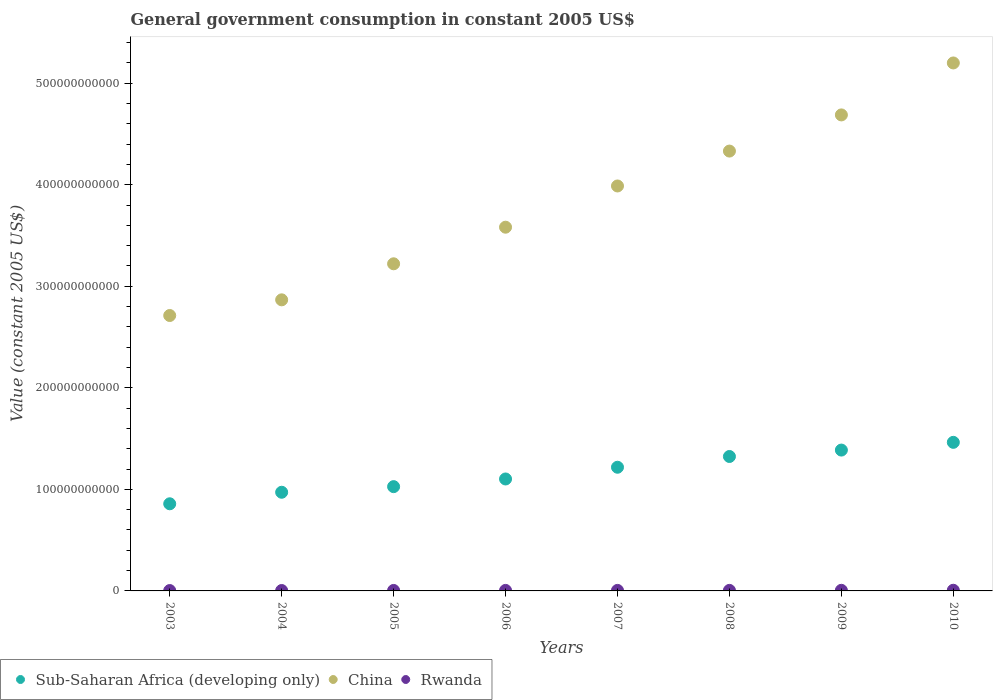What is the government conusmption in Rwanda in 2004?
Offer a terse response. 4.01e+08. Across all years, what is the maximum government conusmption in Sub-Saharan Africa (developing only)?
Ensure brevity in your answer.  1.46e+11. Across all years, what is the minimum government conusmption in China?
Provide a succinct answer. 2.71e+11. What is the total government conusmption in Rwanda in the graph?
Make the answer very short. 4.05e+09. What is the difference between the government conusmption in Sub-Saharan Africa (developing only) in 2005 and that in 2007?
Your response must be concise. -1.91e+1. What is the difference between the government conusmption in China in 2003 and the government conusmption in Rwanda in 2007?
Provide a short and direct response. 2.71e+11. What is the average government conusmption in Sub-Saharan Africa (developing only) per year?
Provide a succinct answer. 1.17e+11. In the year 2009, what is the difference between the government conusmption in Sub-Saharan Africa (developing only) and government conusmption in Rwanda?
Ensure brevity in your answer.  1.38e+11. In how many years, is the government conusmption in China greater than 500000000000 US$?
Your answer should be compact. 1. What is the ratio of the government conusmption in China in 2006 to that in 2010?
Your answer should be compact. 0.69. Is the difference between the government conusmption in Sub-Saharan Africa (developing only) in 2008 and 2009 greater than the difference between the government conusmption in Rwanda in 2008 and 2009?
Provide a succinct answer. No. What is the difference between the highest and the second highest government conusmption in China?
Provide a short and direct response. 5.12e+1. What is the difference between the highest and the lowest government conusmption in Sub-Saharan Africa (developing only)?
Keep it short and to the point. 6.05e+1. In how many years, is the government conusmption in Rwanda greater than the average government conusmption in Rwanda taken over all years?
Your answer should be very brief. 5. Is the government conusmption in China strictly greater than the government conusmption in Rwanda over the years?
Provide a succinct answer. Yes. Is the government conusmption in Sub-Saharan Africa (developing only) strictly less than the government conusmption in China over the years?
Your answer should be compact. Yes. How many dotlines are there?
Provide a succinct answer. 3. What is the difference between two consecutive major ticks on the Y-axis?
Your answer should be compact. 1.00e+11. Are the values on the major ticks of Y-axis written in scientific E-notation?
Your answer should be very brief. No. Does the graph contain any zero values?
Offer a terse response. No. Does the graph contain grids?
Ensure brevity in your answer.  No. How many legend labels are there?
Provide a succinct answer. 3. How are the legend labels stacked?
Provide a short and direct response. Horizontal. What is the title of the graph?
Your answer should be very brief. General government consumption in constant 2005 US$. Does "Kiribati" appear as one of the legend labels in the graph?
Give a very brief answer. No. What is the label or title of the X-axis?
Your response must be concise. Years. What is the label or title of the Y-axis?
Ensure brevity in your answer.  Value (constant 2005 US$). What is the Value (constant 2005 US$) in Sub-Saharan Africa (developing only) in 2003?
Your answer should be very brief. 8.58e+1. What is the Value (constant 2005 US$) of China in 2003?
Offer a very short reply. 2.71e+11. What is the Value (constant 2005 US$) of Rwanda in 2003?
Make the answer very short. 3.66e+08. What is the Value (constant 2005 US$) in Sub-Saharan Africa (developing only) in 2004?
Offer a very short reply. 9.72e+1. What is the Value (constant 2005 US$) of China in 2004?
Make the answer very short. 2.87e+11. What is the Value (constant 2005 US$) of Rwanda in 2004?
Ensure brevity in your answer.  4.01e+08. What is the Value (constant 2005 US$) in Sub-Saharan Africa (developing only) in 2005?
Your answer should be very brief. 1.03e+11. What is the Value (constant 2005 US$) in China in 2005?
Make the answer very short. 3.22e+11. What is the Value (constant 2005 US$) in Rwanda in 2005?
Keep it short and to the point. 4.70e+08. What is the Value (constant 2005 US$) of Sub-Saharan Africa (developing only) in 2006?
Give a very brief answer. 1.10e+11. What is the Value (constant 2005 US$) of China in 2006?
Provide a succinct answer. 3.58e+11. What is the Value (constant 2005 US$) in Rwanda in 2006?
Provide a short and direct response. 5.14e+08. What is the Value (constant 2005 US$) of Sub-Saharan Africa (developing only) in 2007?
Your response must be concise. 1.22e+11. What is the Value (constant 2005 US$) in China in 2007?
Give a very brief answer. 3.99e+11. What is the Value (constant 2005 US$) of Rwanda in 2007?
Provide a short and direct response. 5.19e+08. What is the Value (constant 2005 US$) in Sub-Saharan Africa (developing only) in 2008?
Provide a short and direct response. 1.32e+11. What is the Value (constant 2005 US$) of China in 2008?
Keep it short and to the point. 4.33e+11. What is the Value (constant 2005 US$) in Rwanda in 2008?
Offer a very short reply. 5.32e+08. What is the Value (constant 2005 US$) in Sub-Saharan Africa (developing only) in 2009?
Ensure brevity in your answer.  1.39e+11. What is the Value (constant 2005 US$) of China in 2009?
Offer a very short reply. 4.69e+11. What is the Value (constant 2005 US$) of Rwanda in 2009?
Offer a terse response. 5.94e+08. What is the Value (constant 2005 US$) of Sub-Saharan Africa (developing only) in 2010?
Provide a short and direct response. 1.46e+11. What is the Value (constant 2005 US$) of China in 2010?
Provide a succinct answer. 5.20e+11. What is the Value (constant 2005 US$) of Rwanda in 2010?
Your response must be concise. 6.55e+08. Across all years, what is the maximum Value (constant 2005 US$) of Sub-Saharan Africa (developing only)?
Your answer should be very brief. 1.46e+11. Across all years, what is the maximum Value (constant 2005 US$) of China?
Offer a very short reply. 5.20e+11. Across all years, what is the maximum Value (constant 2005 US$) of Rwanda?
Your answer should be compact. 6.55e+08. Across all years, what is the minimum Value (constant 2005 US$) of Sub-Saharan Africa (developing only)?
Offer a terse response. 8.58e+1. Across all years, what is the minimum Value (constant 2005 US$) of China?
Offer a very short reply. 2.71e+11. Across all years, what is the minimum Value (constant 2005 US$) of Rwanda?
Your answer should be very brief. 3.66e+08. What is the total Value (constant 2005 US$) of Sub-Saharan Africa (developing only) in the graph?
Your answer should be very brief. 9.35e+11. What is the total Value (constant 2005 US$) in China in the graph?
Offer a very short reply. 3.06e+12. What is the total Value (constant 2005 US$) of Rwanda in the graph?
Your answer should be compact. 4.05e+09. What is the difference between the Value (constant 2005 US$) in Sub-Saharan Africa (developing only) in 2003 and that in 2004?
Make the answer very short. -1.13e+1. What is the difference between the Value (constant 2005 US$) of China in 2003 and that in 2004?
Provide a short and direct response. -1.54e+1. What is the difference between the Value (constant 2005 US$) in Rwanda in 2003 and that in 2004?
Your answer should be compact. -3.50e+07. What is the difference between the Value (constant 2005 US$) of Sub-Saharan Africa (developing only) in 2003 and that in 2005?
Your answer should be compact. -1.69e+1. What is the difference between the Value (constant 2005 US$) in China in 2003 and that in 2005?
Your answer should be very brief. -5.09e+1. What is the difference between the Value (constant 2005 US$) in Rwanda in 2003 and that in 2005?
Ensure brevity in your answer.  -1.04e+08. What is the difference between the Value (constant 2005 US$) of Sub-Saharan Africa (developing only) in 2003 and that in 2006?
Provide a short and direct response. -2.44e+1. What is the difference between the Value (constant 2005 US$) in China in 2003 and that in 2006?
Your answer should be very brief. -8.70e+1. What is the difference between the Value (constant 2005 US$) in Rwanda in 2003 and that in 2006?
Make the answer very short. -1.48e+08. What is the difference between the Value (constant 2005 US$) in Sub-Saharan Africa (developing only) in 2003 and that in 2007?
Offer a very short reply. -3.60e+1. What is the difference between the Value (constant 2005 US$) in China in 2003 and that in 2007?
Provide a short and direct response. -1.28e+11. What is the difference between the Value (constant 2005 US$) of Rwanda in 2003 and that in 2007?
Ensure brevity in your answer.  -1.53e+08. What is the difference between the Value (constant 2005 US$) of Sub-Saharan Africa (developing only) in 2003 and that in 2008?
Provide a succinct answer. -4.66e+1. What is the difference between the Value (constant 2005 US$) of China in 2003 and that in 2008?
Your response must be concise. -1.62e+11. What is the difference between the Value (constant 2005 US$) of Rwanda in 2003 and that in 2008?
Your answer should be very brief. -1.66e+08. What is the difference between the Value (constant 2005 US$) in Sub-Saharan Africa (developing only) in 2003 and that in 2009?
Make the answer very short. -5.29e+1. What is the difference between the Value (constant 2005 US$) of China in 2003 and that in 2009?
Keep it short and to the point. -1.98e+11. What is the difference between the Value (constant 2005 US$) of Rwanda in 2003 and that in 2009?
Offer a very short reply. -2.28e+08. What is the difference between the Value (constant 2005 US$) of Sub-Saharan Africa (developing only) in 2003 and that in 2010?
Your answer should be very brief. -6.05e+1. What is the difference between the Value (constant 2005 US$) in China in 2003 and that in 2010?
Make the answer very short. -2.49e+11. What is the difference between the Value (constant 2005 US$) of Rwanda in 2003 and that in 2010?
Your response must be concise. -2.89e+08. What is the difference between the Value (constant 2005 US$) in Sub-Saharan Africa (developing only) in 2004 and that in 2005?
Give a very brief answer. -5.53e+09. What is the difference between the Value (constant 2005 US$) of China in 2004 and that in 2005?
Make the answer very short. -3.55e+1. What is the difference between the Value (constant 2005 US$) of Rwanda in 2004 and that in 2005?
Ensure brevity in your answer.  -6.90e+07. What is the difference between the Value (constant 2005 US$) of Sub-Saharan Africa (developing only) in 2004 and that in 2006?
Your answer should be very brief. -1.31e+1. What is the difference between the Value (constant 2005 US$) of China in 2004 and that in 2006?
Ensure brevity in your answer.  -7.15e+1. What is the difference between the Value (constant 2005 US$) of Rwanda in 2004 and that in 2006?
Your answer should be very brief. -1.13e+08. What is the difference between the Value (constant 2005 US$) in Sub-Saharan Africa (developing only) in 2004 and that in 2007?
Provide a succinct answer. -2.46e+1. What is the difference between the Value (constant 2005 US$) of China in 2004 and that in 2007?
Your answer should be very brief. -1.12e+11. What is the difference between the Value (constant 2005 US$) in Rwanda in 2004 and that in 2007?
Ensure brevity in your answer.  -1.18e+08. What is the difference between the Value (constant 2005 US$) of Sub-Saharan Africa (developing only) in 2004 and that in 2008?
Keep it short and to the point. -3.52e+1. What is the difference between the Value (constant 2005 US$) of China in 2004 and that in 2008?
Keep it short and to the point. -1.46e+11. What is the difference between the Value (constant 2005 US$) of Rwanda in 2004 and that in 2008?
Provide a succinct answer. -1.31e+08. What is the difference between the Value (constant 2005 US$) of Sub-Saharan Africa (developing only) in 2004 and that in 2009?
Your answer should be compact. -4.15e+1. What is the difference between the Value (constant 2005 US$) in China in 2004 and that in 2009?
Make the answer very short. -1.82e+11. What is the difference between the Value (constant 2005 US$) of Rwanda in 2004 and that in 2009?
Provide a succinct answer. -1.93e+08. What is the difference between the Value (constant 2005 US$) in Sub-Saharan Africa (developing only) in 2004 and that in 2010?
Give a very brief answer. -4.92e+1. What is the difference between the Value (constant 2005 US$) of China in 2004 and that in 2010?
Provide a succinct answer. -2.33e+11. What is the difference between the Value (constant 2005 US$) of Rwanda in 2004 and that in 2010?
Make the answer very short. -2.54e+08. What is the difference between the Value (constant 2005 US$) of Sub-Saharan Africa (developing only) in 2005 and that in 2006?
Keep it short and to the point. -7.55e+09. What is the difference between the Value (constant 2005 US$) of China in 2005 and that in 2006?
Offer a terse response. -3.60e+1. What is the difference between the Value (constant 2005 US$) of Rwanda in 2005 and that in 2006?
Keep it short and to the point. -4.40e+07. What is the difference between the Value (constant 2005 US$) of Sub-Saharan Africa (developing only) in 2005 and that in 2007?
Make the answer very short. -1.91e+1. What is the difference between the Value (constant 2005 US$) in China in 2005 and that in 2007?
Your response must be concise. -7.66e+1. What is the difference between the Value (constant 2005 US$) in Rwanda in 2005 and that in 2007?
Your answer should be compact. -4.92e+07. What is the difference between the Value (constant 2005 US$) of Sub-Saharan Africa (developing only) in 2005 and that in 2008?
Give a very brief answer. -2.97e+1. What is the difference between the Value (constant 2005 US$) of China in 2005 and that in 2008?
Your answer should be very brief. -1.11e+11. What is the difference between the Value (constant 2005 US$) in Rwanda in 2005 and that in 2008?
Give a very brief answer. -6.21e+07. What is the difference between the Value (constant 2005 US$) of Sub-Saharan Africa (developing only) in 2005 and that in 2009?
Provide a succinct answer. -3.60e+1. What is the difference between the Value (constant 2005 US$) in China in 2005 and that in 2009?
Your response must be concise. -1.47e+11. What is the difference between the Value (constant 2005 US$) in Rwanda in 2005 and that in 2009?
Make the answer very short. -1.24e+08. What is the difference between the Value (constant 2005 US$) in Sub-Saharan Africa (developing only) in 2005 and that in 2010?
Your answer should be compact. -4.36e+1. What is the difference between the Value (constant 2005 US$) in China in 2005 and that in 2010?
Provide a succinct answer. -1.98e+11. What is the difference between the Value (constant 2005 US$) in Rwanda in 2005 and that in 2010?
Keep it short and to the point. -1.85e+08. What is the difference between the Value (constant 2005 US$) of Sub-Saharan Africa (developing only) in 2006 and that in 2007?
Offer a terse response. -1.16e+1. What is the difference between the Value (constant 2005 US$) of China in 2006 and that in 2007?
Ensure brevity in your answer.  -4.06e+1. What is the difference between the Value (constant 2005 US$) of Rwanda in 2006 and that in 2007?
Your response must be concise. -5.18e+06. What is the difference between the Value (constant 2005 US$) in Sub-Saharan Africa (developing only) in 2006 and that in 2008?
Keep it short and to the point. -2.21e+1. What is the difference between the Value (constant 2005 US$) in China in 2006 and that in 2008?
Offer a terse response. -7.50e+1. What is the difference between the Value (constant 2005 US$) in Rwanda in 2006 and that in 2008?
Keep it short and to the point. -1.81e+07. What is the difference between the Value (constant 2005 US$) of Sub-Saharan Africa (developing only) in 2006 and that in 2009?
Give a very brief answer. -2.85e+1. What is the difference between the Value (constant 2005 US$) in China in 2006 and that in 2009?
Your answer should be very brief. -1.11e+11. What is the difference between the Value (constant 2005 US$) in Rwanda in 2006 and that in 2009?
Your answer should be compact. -8.02e+07. What is the difference between the Value (constant 2005 US$) in Sub-Saharan Africa (developing only) in 2006 and that in 2010?
Your response must be concise. -3.61e+1. What is the difference between the Value (constant 2005 US$) of China in 2006 and that in 2010?
Offer a terse response. -1.62e+11. What is the difference between the Value (constant 2005 US$) of Rwanda in 2006 and that in 2010?
Offer a very short reply. -1.41e+08. What is the difference between the Value (constant 2005 US$) in Sub-Saharan Africa (developing only) in 2007 and that in 2008?
Provide a succinct answer. -1.06e+1. What is the difference between the Value (constant 2005 US$) in China in 2007 and that in 2008?
Give a very brief answer. -3.44e+1. What is the difference between the Value (constant 2005 US$) in Rwanda in 2007 and that in 2008?
Keep it short and to the point. -1.29e+07. What is the difference between the Value (constant 2005 US$) of Sub-Saharan Africa (developing only) in 2007 and that in 2009?
Offer a terse response. -1.69e+1. What is the difference between the Value (constant 2005 US$) in China in 2007 and that in 2009?
Your response must be concise. -7.00e+1. What is the difference between the Value (constant 2005 US$) in Rwanda in 2007 and that in 2009?
Keep it short and to the point. -7.50e+07. What is the difference between the Value (constant 2005 US$) in Sub-Saharan Africa (developing only) in 2007 and that in 2010?
Give a very brief answer. -2.45e+1. What is the difference between the Value (constant 2005 US$) of China in 2007 and that in 2010?
Offer a terse response. -1.21e+11. What is the difference between the Value (constant 2005 US$) of Rwanda in 2007 and that in 2010?
Offer a terse response. -1.36e+08. What is the difference between the Value (constant 2005 US$) of Sub-Saharan Africa (developing only) in 2008 and that in 2009?
Keep it short and to the point. -6.32e+09. What is the difference between the Value (constant 2005 US$) of China in 2008 and that in 2009?
Offer a very short reply. -3.56e+1. What is the difference between the Value (constant 2005 US$) in Rwanda in 2008 and that in 2009?
Give a very brief answer. -6.21e+07. What is the difference between the Value (constant 2005 US$) in Sub-Saharan Africa (developing only) in 2008 and that in 2010?
Your answer should be very brief. -1.39e+1. What is the difference between the Value (constant 2005 US$) of China in 2008 and that in 2010?
Keep it short and to the point. -8.68e+1. What is the difference between the Value (constant 2005 US$) of Rwanda in 2008 and that in 2010?
Your answer should be compact. -1.23e+08. What is the difference between the Value (constant 2005 US$) in Sub-Saharan Africa (developing only) in 2009 and that in 2010?
Offer a very short reply. -7.61e+09. What is the difference between the Value (constant 2005 US$) in China in 2009 and that in 2010?
Ensure brevity in your answer.  -5.12e+1. What is the difference between the Value (constant 2005 US$) of Rwanda in 2009 and that in 2010?
Your answer should be very brief. -6.08e+07. What is the difference between the Value (constant 2005 US$) of Sub-Saharan Africa (developing only) in 2003 and the Value (constant 2005 US$) of China in 2004?
Make the answer very short. -2.01e+11. What is the difference between the Value (constant 2005 US$) in Sub-Saharan Africa (developing only) in 2003 and the Value (constant 2005 US$) in Rwanda in 2004?
Your response must be concise. 8.54e+1. What is the difference between the Value (constant 2005 US$) of China in 2003 and the Value (constant 2005 US$) of Rwanda in 2004?
Ensure brevity in your answer.  2.71e+11. What is the difference between the Value (constant 2005 US$) in Sub-Saharan Africa (developing only) in 2003 and the Value (constant 2005 US$) in China in 2005?
Offer a very short reply. -2.36e+11. What is the difference between the Value (constant 2005 US$) in Sub-Saharan Africa (developing only) in 2003 and the Value (constant 2005 US$) in Rwanda in 2005?
Keep it short and to the point. 8.53e+1. What is the difference between the Value (constant 2005 US$) in China in 2003 and the Value (constant 2005 US$) in Rwanda in 2005?
Offer a very short reply. 2.71e+11. What is the difference between the Value (constant 2005 US$) in Sub-Saharan Africa (developing only) in 2003 and the Value (constant 2005 US$) in China in 2006?
Your answer should be very brief. -2.72e+11. What is the difference between the Value (constant 2005 US$) of Sub-Saharan Africa (developing only) in 2003 and the Value (constant 2005 US$) of Rwanda in 2006?
Your answer should be compact. 8.53e+1. What is the difference between the Value (constant 2005 US$) in China in 2003 and the Value (constant 2005 US$) in Rwanda in 2006?
Your answer should be compact. 2.71e+11. What is the difference between the Value (constant 2005 US$) in Sub-Saharan Africa (developing only) in 2003 and the Value (constant 2005 US$) in China in 2007?
Ensure brevity in your answer.  -3.13e+11. What is the difference between the Value (constant 2005 US$) in Sub-Saharan Africa (developing only) in 2003 and the Value (constant 2005 US$) in Rwanda in 2007?
Provide a succinct answer. 8.53e+1. What is the difference between the Value (constant 2005 US$) of China in 2003 and the Value (constant 2005 US$) of Rwanda in 2007?
Make the answer very short. 2.71e+11. What is the difference between the Value (constant 2005 US$) of Sub-Saharan Africa (developing only) in 2003 and the Value (constant 2005 US$) of China in 2008?
Your response must be concise. -3.47e+11. What is the difference between the Value (constant 2005 US$) in Sub-Saharan Africa (developing only) in 2003 and the Value (constant 2005 US$) in Rwanda in 2008?
Provide a short and direct response. 8.53e+1. What is the difference between the Value (constant 2005 US$) of China in 2003 and the Value (constant 2005 US$) of Rwanda in 2008?
Ensure brevity in your answer.  2.71e+11. What is the difference between the Value (constant 2005 US$) of Sub-Saharan Africa (developing only) in 2003 and the Value (constant 2005 US$) of China in 2009?
Offer a terse response. -3.83e+11. What is the difference between the Value (constant 2005 US$) in Sub-Saharan Africa (developing only) in 2003 and the Value (constant 2005 US$) in Rwanda in 2009?
Offer a terse response. 8.52e+1. What is the difference between the Value (constant 2005 US$) of China in 2003 and the Value (constant 2005 US$) of Rwanda in 2009?
Offer a very short reply. 2.71e+11. What is the difference between the Value (constant 2005 US$) of Sub-Saharan Africa (developing only) in 2003 and the Value (constant 2005 US$) of China in 2010?
Offer a very short reply. -4.34e+11. What is the difference between the Value (constant 2005 US$) in Sub-Saharan Africa (developing only) in 2003 and the Value (constant 2005 US$) in Rwanda in 2010?
Your answer should be compact. 8.52e+1. What is the difference between the Value (constant 2005 US$) in China in 2003 and the Value (constant 2005 US$) in Rwanda in 2010?
Your answer should be compact. 2.71e+11. What is the difference between the Value (constant 2005 US$) in Sub-Saharan Africa (developing only) in 2004 and the Value (constant 2005 US$) in China in 2005?
Ensure brevity in your answer.  -2.25e+11. What is the difference between the Value (constant 2005 US$) of Sub-Saharan Africa (developing only) in 2004 and the Value (constant 2005 US$) of Rwanda in 2005?
Your answer should be very brief. 9.67e+1. What is the difference between the Value (constant 2005 US$) of China in 2004 and the Value (constant 2005 US$) of Rwanda in 2005?
Give a very brief answer. 2.86e+11. What is the difference between the Value (constant 2005 US$) in Sub-Saharan Africa (developing only) in 2004 and the Value (constant 2005 US$) in China in 2006?
Your answer should be very brief. -2.61e+11. What is the difference between the Value (constant 2005 US$) in Sub-Saharan Africa (developing only) in 2004 and the Value (constant 2005 US$) in Rwanda in 2006?
Your answer should be very brief. 9.67e+1. What is the difference between the Value (constant 2005 US$) in China in 2004 and the Value (constant 2005 US$) in Rwanda in 2006?
Provide a short and direct response. 2.86e+11. What is the difference between the Value (constant 2005 US$) of Sub-Saharan Africa (developing only) in 2004 and the Value (constant 2005 US$) of China in 2007?
Provide a short and direct response. -3.02e+11. What is the difference between the Value (constant 2005 US$) of Sub-Saharan Africa (developing only) in 2004 and the Value (constant 2005 US$) of Rwanda in 2007?
Your response must be concise. 9.66e+1. What is the difference between the Value (constant 2005 US$) in China in 2004 and the Value (constant 2005 US$) in Rwanda in 2007?
Provide a short and direct response. 2.86e+11. What is the difference between the Value (constant 2005 US$) of Sub-Saharan Africa (developing only) in 2004 and the Value (constant 2005 US$) of China in 2008?
Provide a short and direct response. -3.36e+11. What is the difference between the Value (constant 2005 US$) in Sub-Saharan Africa (developing only) in 2004 and the Value (constant 2005 US$) in Rwanda in 2008?
Provide a short and direct response. 9.66e+1. What is the difference between the Value (constant 2005 US$) in China in 2004 and the Value (constant 2005 US$) in Rwanda in 2008?
Keep it short and to the point. 2.86e+11. What is the difference between the Value (constant 2005 US$) of Sub-Saharan Africa (developing only) in 2004 and the Value (constant 2005 US$) of China in 2009?
Your answer should be compact. -3.72e+11. What is the difference between the Value (constant 2005 US$) in Sub-Saharan Africa (developing only) in 2004 and the Value (constant 2005 US$) in Rwanda in 2009?
Keep it short and to the point. 9.66e+1. What is the difference between the Value (constant 2005 US$) of China in 2004 and the Value (constant 2005 US$) of Rwanda in 2009?
Your answer should be compact. 2.86e+11. What is the difference between the Value (constant 2005 US$) in Sub-Saharan Africa (developing only) in 2004 and the Value (constant 2005 US$) in China in 2010?
Your answer should be very brief. -4.23e+11. What is the difference between the Value (constant 2005 US$) in Sub-Saharan Africa (developing only) in 2004 and the Value (constant 2005 US$) in Rwanda in 2010?
Your answer should be compact. 9.65e+1. What is the difference between the Value (constant 2005 US$) of China in 2004 and the Value (constant 2005 US$) of Rwanda in 2010?
Your answer should be compact. 2.86e+11. What is the difference between the Value (constant 2005 US$) in Sub-Saharan Africa (developing only) in 2005 and the Value (constant 2005 US$) in China in 2006?
Provide a short and direct response. -2.56e+11. What is the difference between the Value (constant 2005 US$) of Sub-Saharan Africa (developing only) in 2005 and the Value (constant 2005 US$) of Rwanda in 2006?
Make the answer very short. 1.02e+11. What is the difference between the Value (constant 2005 US$) of China in 2005 and the Value (constant 2005 US$) of Rwanda in 2006?
Your response must be concise. 3.22e+11. What is the difference between the Value (constant 2005 US$) in Sub-Saharan Africa (developing only) in 2005 and the Value (constant 2005 US$) in China in 2007?
Give a very brief answer. -2.96e+11. What is the difference between the Value (constant 2005 US$) in Sub-Saharan Africa (developing only) in 2005 and the Value (constant 2005 US$) in Rwanda in 2007?
Give a very brief answer. 1.02e+11. What is the difference between the Value (constant 2005 US$) of China in 2005 and the Value (constant 2005 US$) of Rwanda in 2007?
Provide a succinct answer. 3.22e+11. What is the difference between the Value (constant 2005 US$) of Sub-Saharan Africa (developing only) in 2005 and the Value (constant 2005 US$) of China in 2008?
Provide a short and direct response. -3.30e+11. What is the difference between the Value (constant 2005 US$) of Sub-Saharan Africa (developing only) in 2005 and the Value (constant 2005 US$) of Rwanda in 2008?
Offer a very short reply. 1.02e+11. What is the difference between the Value (constant 2005 US$) in China in 2005 and the Value (constant 2005 US$) in Rwanda in 2008?
Provide a succinct answer. 3.22e+11. What is the difference between the Value (constant 2005 US$) in Sub-Saharan Africa (developing only) in 2005 and the Value (constant 2005 US$) in China in 2009?
Your response must be concise. -3.66e+11. What is the difference between the Value (constant 2005 US$) of Sub-Saharan Africa (developing only) in 2005 and the Value (constant 2005 US$) of Rwanda in 2009?
Your answer should be very brief. 1.02e+11. What is the difference between the Value (constant 2005 US$) of China in 2005 and the Value (constant 2005 US$) of Rwanda in 2009?
Ensure brevity in your answer.  3.22e+11. What is the difference between the Value (constant 2005 US$) of Sub-Saharan Africa (developing only) in 2005 and the Value (constant 2005 US$) of China in 2010?
Provide a succinct answer. -4.17e+11. What is the difference between the Value (constant 2005 US$) in Sub-Saharan Africa (developing only) in 2005 and the Value (constant 2005 US$) in Rwanda in 2010?
Provide a succinct answer. 1.02e+11. What is the difference between the Value (constant 2005 US$) of China in 2005 and the Value (constant 2005 US$) of Rwanda in 2010?
Keep it short and to the point. 3.22e+11. What is the difference between the Value (constant 2005 US$) in Sub-Saharan Africa (developing only) in 2006 and the Value (constant 2005 US$) in China in 2007?
Give a very brief answer. -2.89e+11. What is the difference between the Value (constant 2005 US$) of Sub-Saharan Africa (developing only) in 2006 and the Value (constant 2005 US$) of Rwanda in 2007?
Your answer should be very brief. 1.10e+11. What is the difference between the Value (constant 2005 US$) of China in 2006 and the Value (constant 2005 US$) of Rwanda in 2007?
Give a very brief answer. 3.58e+11. What is the difference between the Value (constant 2005 US$) of Sub-Saharan Africa (developing only) in 2006 and the Value (constant 2005 US$) of China in 2008?
Your answer should be very brief. -3.23e+11. What is the difference between the Value (constant 2005 US$) of Sub-Saharan Africa (developing only) in 2006 and the Value (constant 2005 US$) of Rwanda in 2008?
Your answer should be compact. 1.10e+11. What is the difference between the Value (constant 2005 US$) of China in 2006 and the Value (constant 2005 US$) of Rwanda in 2008?
Your response must be concise. 3.58e+11. What is the difference between the Value (constant 2005 US$) of Sub-Saharan Africa (developing only) in 2006 and the Value (constant 2005 US$) of China in 2009?
Your answer should be very brief. -3.59e+11. What is the difference between the Value (constant 2005 US$) in Sub-Saharan Africa (developing only) in 2006 and the Value (constant 2005 US$) in Rwanda in 2009?
Give a very brief answer. 1.10e+11. What is the difference between the Value (constant 2005 US$) in China in 2006 and the Value (constant 2005 US$) in Rwanda in 2009?
Ensure brevity in your answer.  3.58e+11. What is the difference between the Value (constant 2005 US$) of Sub-Saharan Africa (developing only) in 2006 and the Value (constant 2005 US$) of China in 2010?
Your response must be concise. -4.10e+11. What is the difference between the Value (constant 2005 US$) in Sub-Saharan Africa (developing only) in 2006 and the Value (constant 2005 US$) in Rwanda in 2010?
Offer a very short reply. 1.10e+11. What is the difference between the Value (constant 2005 US$) of China in 2006 and the Value (constant 2005 US$) of Rwanda in 2010?
Offer a very short reply. 3.58e+11. What is the difference between the Value (constant 2005 US$) in Sub-Saharan Africa (developing only) in 2007 and the Value (constant 2005 US$) in China in 2008?
Offer a terse response. -3.11e+11. What is the difference between the Value (constant 2005 US$) in Sub-Saharan Africa (developing only) in 2007 and the Value (constant 2005 US$) in Rwanda in 2008?
Offer a terse response. 1.21e+11. What is the difference between the Value (constant 2005 US$) in China in 2007 and the Value (constant 2005 US$) in Rwanda in 2008?
Provide a short and direct response. 3.98e+11. What is the difference between the Value (constant 2005 US$) in Sub-Saharan Africa (developing only) in 2007 and the Value (constant 2005 US$) in China in 2009?
Your answer should be compact. -3.47e+11. What is the difference between the Value (constant 2005 US$) in Sub-Saharan Africa (developing only) in 2007 and the Value (constant 2005 US$) in Rwanda in 2009?
Keep it short and to the point. 1.21e+11. What is the difference between the Value (constant 2005 US$) in China in 2007 and the Value (constant 2005 US$) in Rwanda in 2009?
Your answer should be compact. 3.98e+11. What is the difference between the Value (constant 2005 US$) of Sub-Saharan Africa (developing only) in 2007 and the Value (constant 2005 US$) of China in 2010?
Your answer should be very brief. -3.98e+11. What is the difference between the Value (constant 2005 US$) of Sub-Saharan Africa (developing only) in 2007 and the Value (constant 2005 US$) of Rwanda in 2010?
Ensure brevity in your answer.  1.21e+11. What is the difference between the Value (constant 2005 US$) in China in 2007 and the Value (constant 2005 US$) in Rwanda in 2010?
Offer a terse response. 3.98e+11. What is the difference between the Value (constant 2005 US$) of Sub-Saharan Africa (developing only) in 2008 and the Value (constant 2005 US$) of China in 2009?
Make the answer very short. -3.36e+11. What is the difference between the Value (constant 2005 US$) in Sub-Saharan Africa (developing only) in 2008 and the Value (constant 2005 US$) in Rwanda in 2009?
Provide a short and direct response. 1.32e+11. What is the difference between the Value (constant 2005 US$) in China in 2008 and the Value (constant 2005 US$) in Rwanda in 2009?
Ensure brevity in your answer.  4.33e+11. What is the difference between the Value (constant 2005 US$) in Sub-Saharan Africa (developing only) in 2008 and the Value (constant 2005 US$) in China in 2010?
Offer a very short reply. -3.88e+11. What is the difference between the Value (constant 2005 US$) in Sub-Saharan Africa (developing only) in 2008 and the Value (constant 2005 US$) in Rwanda in 2010?
Your answer should be compact. 1.32e+11. What is the difference between the Value (constant 2005 US$) in China in 2008 and the Value (constant 2005 US$) in Rwanda in 2010?
Provide a short and direct response. 4.33e+11. What is the difference between the Value (constant 2005 US$) in Sub-Saharan Africa (developing only) in 2009 and the Value (constant 2005 US$) in China in 2010?
Ensure brevity in your answer.  -3.81e+11. What is the difference between the Value (constant 2005 US$) of Sub-Saharan Africa (developing only) in 2009 and the Value (constant 2005 US$) of Rwanda in 2010?
Your answer should be very brief. 1.38e+11. What is the difference between the Value (constant 2005 US$) in China in 2009 and the Value (constant 2005 US$) in Rwanda in 2010?
Give a very brief answer. 4.68e+11. What is the average Value (constant 2005 US$) of Sub-Saharan Africa (developing only) per year?
Provide a succinct answer. 1.17e+11. What is the average Value (constant 2005 US$) in China per year?
Your answer should be very brief. 3.82e+11. What is the average Value (constant 2005 US$) in Rwanda per year?
Provide a succinct answer. 5.06e+08. In the year 2003, what is the difference between the Value (constant 2005 US$) of Sub-Saharan Africa (developing only) and Value (constant 2005 US$) of China?
Keep it short and to the point. -1.85e+11. In the year 2003, what is the difference between the Value (constant 2005 US$) in Sub-Saharan Africa (developing only) and Value (constant 2005 US$) in Rwanda?
Keep it short and to the point. 8.55e+1. In the year 2003, what is the difference between the Value (constant 2005 US$) of China and Value (constant 2005 US$) of Rwanda?
Offer a very short reply. 2.71e+11. In the year 2004, what is the difference between the Value (constant 2005 US$) of Sub-Saharan Africa (developing only) and Value (constant 2005 US$) of China?
Ensure brevity in your answer.  -1.90e+11. In the year 2004, what is the difference between the Value (constant 2005 US$) of Sub-Saharan Africa (developing only) and Value (constant 2005 US$) of Rwanda?
Your response must be concise. 9.68e+1. In the year 2004, what is the difference between the Value (constant 2005 US$) of China and Value (constant 2005 US$) of Rwanda?
Your answer should be compact. 2.86e+11. In the year 2005, what is the difference between the Value (constant 2005 US$) of Sub-Saharan Africa (developing only) and Value (constant 2005 US$) of China?
Your answer should be very brief. -2.19e+11. In the year 2005, what is the difference between the Value (constant 2005 US$) of Sub-Saharan Africa (developing only) and Value (constant 2005 US$) of Rwanda?
Give a very brief answer. 1.02e+11. In the year 2005, what is the difference between the Value (constant 2005 US$) in China and Value (constant 2005 US$) in Rwanda?
Provide a short and direct response. 3.22e+11. In the year 2006, what is the difference between the Value (constant 2005 US$) of Sub-Saharan Africa (developing only) and Value (constant 2005 US$) of China?
Your answer should be compact. -2.48e+11. In the year 2006, what is the difference between the Value (constant 2005 US$) in Sub-Saharan Africa (developing only) and Value (constant 2005 US$) in Rwanda?
Your response must be concise. 1.10e+11. In the year 2006, what is the difference between the Value (constant 2005 US$) of China and Value (constant 2005 US$) of Rwanda?
Provide a short and direct response. 3.58e+11. In the year 2007, what is the difference between the Value (constant 2005 US$) of Sub-Saharan Africa (developing only) and Value (constant 2005 US$) of China?
Your answer should be compact. -2.77e+11. In the year 2007, what is the difference between the Value (constant 2005 US$) of Sub-Saharan Africa (developing only) and Value (constant 2005 US$) of Rwanda?
Make the answer very short. 1.21e+11. In the year 2007, what is the difference between the Value (constant 2005 US$) of China and Value (constant 2005 US$) of Rwanda?
Your answer should be compact. 3.98e+11. In the year 2008, what is the difference between the Value (constant 2005 US$) of Sub-Saharan Africa (developing only) and Value (constant 2005 US$) of China?
Provide a short and direct response. -3.01e+11. In the year 2008, what is the difference between the Value (constant 2005 US$) of Sub-Saharan Africa (developing only) and Value (constant 2005 US$) of Rwanda?
Provide a short and direct response. 1.32e+11. In the year 2008, what is the difference between the Value (constant 2005 US$) in China and Value (constant 2005 US$) in Rwanda?
Your response must be concise. 4.33e+11. In the year 2009, what is the difference between the Value (constant 2005 US$) in Sub-Saharan Africa (developing only) and Value (constant 2005 US$) in China?
Provide a succinct answer. -3.30e+11. In the year 2009, what is the difference between the Value (constant 2005 US$) in Sub-Saharan Africa (developing only) and Value (constant 2005 US$) in Rwanda?
Provide a succinct answer. 1.38e+11. In the year 2009, what is the difference between the Value (constant 2005 US$) in China and Value (constant 2005 US$) in Rwanda?
Your response must be concise. 4.68e+11. In the year 2010, what is the difference between the Value (constant 2005 US$) in Sub-Saharan Africa (developing only) and Value (constant 2005 US$) in China?
Give a very brief answer. -3.74e+11. In the year 2010, what is the difference between the Value (constant 2005 US$) in Sub-Saharan Africa (developing only) and Value (constant 2005 US$) in Rwanda?
Offer a very short reply. 1.46e+11. In the year 2010, what is the difference between the Value (constant 2005 US$) in China and Value (constant 2005 US$) in Rwanda?
Provide a succinct answer. 5.19e+11. What is the ratio of the Value (constant 2005 US$) in Sub-Saharan Africa (developing only) in 2003 to that in 2004?
Offer a very short reply. 0.88. What is the ratio of the Value (constant 2005 US$) of China in 2003 to that in 2004?
Give a very brief answer. 0.95. What is the ratio of the Value (constant 2005 US$) of Rwanda in 2003 to that in 2004?
Offer a very short reply. 0.91. What is the ratio of the Value (constant 2005 US$) of Sub-Saharan Africa (developing only) in 2003 to that in 2005?
Give a very brief answer. 0.84. What is the ratio of the Value (constant 2005 US$) in China in 2003 to that in 2005?
Give a very brief answer. 0.84. What is the ratio of the Value (constant 2005 US$) in Rwanda in 2003 to that in 2005?
Keep it short and to the point. 0.78. What is the ratio of the Value (constant 2005 US$) in Sub-Saharan Africa (developing only) in 2003 to that in 2006?
Your answer should be compact. 0.78. What is the ratio of the Value (constant 2005 US$) of China in 2003 to that in 2006?
Keep it short and to the point. 0.76. What is the ratio of the Value (constant 2005 US$) in Rwanda in 2003 to that in 2006?
Provide a succinct answer. 0.71. What is the ratio of the Value (constant 2005 US$) in Sub-Saharan Africa (developing only) in 2003 to that in 2007?
Your answer should be compact. 0.7. What is the ratio of the Value (constant 2005 US$) of China in 2003 to that in 2007?
Your answer should be very brief. 0.68. What is the ratio of the Value (constant 2005 US$) of Rwanda in 2003 to that in 2007?
Offer a very short reply. 0.7. What is the ratio of the Value (constant 2005 US$) in Sub-Saharan Africa (developing only) in 2003 to that in 2008?
Your response must be concise. 0.65. What is the ratio of the Value (constant 2005 US$) in China in 2003 to that in 2008?
Offer a terse response. 0.63. What is the ratio of the Value (constant 2005 US$) of Rwanda in 2003 to that in 2008?
Your response must be concise. 0.69. What is the ratio of the Value (constant 2005 US$) of Sub-Saharan Africa (developing only) in 2003 to that in 2009?
Provide a succinct answer. 0.62. What is the ratio of the Value (constant 2005 US$) of China in 2003 to that in 2009?
Your answer should be very brief. 0.58. What is the ratio of the Value (constant 2005 US$) in Rwanda in 2003 to that in 2009?
Make the answer very short. 0.62. What is the ratio of the Value (constant 2005 US$) of Sub-Saharan Africa (developing only) in 2003 to that in 2010?
Your response must be concise. 0.59. What is the ratio of the Value (constant 2005 US$) in China in 2003 to that in 2010?
Offer a terse response. 0.52. What is the ratio of the Value (constant 2005 US$) in Rwanda in 2003 to that in 2010?
Your answer should be very brief. 0.56. What is the ratio of the Value (constant 2005 US$) of Sub-Saharan Africa (developing only) in 2004 to that in 2005?
Offer a terse response. 0.95. What is the ratio of the Value (constant 2005 US$) in China in 2004 to that in 2005?
Make the answer very short. 0.89. What is the ratio of the Value (constant 2005 US$) in Rwanda in 2004 to that in 2005?
Your response must be concise. 0.85. What is the ratio of the Value (constant 2005 US$) in Sub-Saharan Africa (developing only) in 2004 to that in 2006?
Offer a terse response. 0.88. What is the ratio of the Value (constant 2005 US$) in China in 2004 to that in 2006?
Provide a succinct answer. 0.8. What is the ratio of the Value (constant 2005 US$) in Rwanda in 2004 to that in 2006?
Make the answer very short. 0.78. What is the ratio of the Value (constant 2005 US$) of Sub-Saharan Africa (developing only) in 2004 to that in 2007?
Your response must be concise. 0.8. What is the ratio of the Value (constant 2005 US$) of China in 2004 to that in 2007?
Provide a short and direct response. 0.72. What is the ratio of the Value (constant 2005 US$) of Rwanda in 2004 to that in 2007?
Keep it short and to the point. 0.77. What is the ratio of the Value (constant 2005 US$) in Sub-Saharan Africa (developing only) in 2004 to that in 2008?
Provide a short and direct response. 0.73. What is the ratio of the Value (constant 2005 US$) of China in 2004 to that in 2008?
Offer a very short reply. 0.66. What is the ratio of the Value (constant 2005 US$) in Rwanda in 2004 to that in 2008?
Your answer should be very brief. 0.75. What is the ratio of the Value (constant 2005 US$) of Sub-Saharan Africa (developing only) in 2004 to that in 2009?
Provide a short and direct response. 0.7. What is the ratio of the Value (constant 2005 US$) in China in 2004 to that in 2009?
Your answer should be very brief. 0.61. What is the ratio of the Value (constant 2005 US$) of Rwanda in 2004 to that in 2009?
Provide a succinct answer. 0.67. What is the ratio of the Value (constant 2005 US$) of Sub-Saharan Africa (developing only) in 2004 to that in 2010?
Provide a short and direct response. 0.66. What is the ratio of the Value (constant 2005 US$) in China in 2004 to that in 2010?
Provide a short and direct response. 0.55. What is the ratio of the Value (constant 2005 US$) in Rwanda in 2004 to that in 2010?
Your answer should be compact. 0.61. What is the ratio of the Value (constant 2005 US$) in Sub-Saharan Africa (developing only) in 2005 to that in 2006?
Keep it short and to the point. 0.93. What is the ratio of the Value (constant 2005 US$) of China in 2005 to that in 2006?
Keep it short and to the point. 0.9. What is the ratio of the Value (constant 2005 US$) of Rwanda in 2005 to that in 2006?
Your response must be concise. 0.91. What is the ratio of the Value (constant 2005 US$) in Sub-Saharan Africa (developing only) in 2005 to that in 2007?
Provide a short and direct response. 0.84. What is the ratio of the Value (constant 2005 US$) of China in 2005 to that in 2007?
Offer a very short reply. 0.81. What is the ratio of the Value (constant 2005 US$) of Rwanda in 2005 to that in 2007?
Your answer should be very brief. 0.91. What is the ratio of the Value (constant 2005 US$) of Sub-Saharan Africa (developing only) in 2005 to that in 2008?
Offer a very short reply. 0.78. What is the ratio of the Value (constant 2005 US$) of China in 2005 to that in 2008?
Provide a succinct answer. 0.74. What is the ratio of the Value (constant 2005 US$) of Rwanda in 2005 to that in 2008?
Ensure brevity in your answer.  0.88. What is the ratio of the Value (constant 2005 US$) in Sub-Saharan Africa (developing only) in 2005 to that in 2009?
Keep it short and to the point. 0.74. What is the ratio of the Value (constant 2005 US$) of China in 2005 to that in 2009?
Offer a terse response. 0.69. What is the ratio of the Value (constant 2005 US$) in Rwanda in 2005 to that in 2009?
Make the answer very short. 0.79. What is the ratio of the Value (constant 2005 US$) of Sub-Saharan Africa (developing only) in 2005 to that in 2010?
Your response must be concise. 0.7. What is the ratio of the Value (constant 2005 US$) of China in 2005 to that in 2010?
Your response must be concise. 0.62. What is the ratio of the Value (constant 2005 US$) in Rwanda in 2005 to that in 2010?
Ensure brevity in your answer.  0.72. What is the ratio of the Value (constant 2005 US$) of Sub-Saharan Africa (developing only) in 2006 to that in 2007?
Your answer should be compact. 0.91. What is the ratio of the Value (constant 2005 US$) in China in 2006 to that in 2007?
Your answer should be compact. 0.9. What is the ratio of the Value (constant 2005 US$) in Rwanda in 2006 to that in 2007?
Provide a short and direct response. 0.99. What is the ratio of the Value (constant 2005 US$) of Sub-Saharan Africa (developing only) in 2006 to that in 2008?
Your response must be concise. 0.83. What is the ratio of the Value (constant 2005 US$) in China in 2006 to that in 2008?
Your answer should be very brief. 0.83. What is the ratio of the Value (constant 2005 US$) of Rwanda in 2006 to that in 2008?
Offer a very short reply. 0.97. What is the ratio of the Value (constant 2005 US$) of Sub-Saharan Africa (developing only) in 2006 to that in 2009?
Your answer should be compact. 0.79. What is the ratio of the Value (constant 2005 US$) of China in 2006 to that in 2009?
Your answer should be very brief. 0.76. What is the ratio of the Value (constant 2005 US$) in Rwanda in 2006 to that in 2009?
Your response must be concise. 0.86. What is the ratio of the Value (constant 2005 US$) of Sub-Saharan Africa (developing only) in 2006 to that in 2010?
Your answer should be very brief. 0.75. What is the ratio of the Value (constant 2005 US$) of China in 2006 to that in 2010?
Keep it short and to the point. 0.69. What is the ratio of the Value (constant 2005 US$) in Rwanda in 2006 to that in 2010?
Your answer should be very brief. 0.78. What is the ratio of the Value (constant 2005 US$) of China in 2007 to that in 2008?
Give a very brief answer. 0.92. What is the ratio of the Value (constant 2005 US$) of Rwanda in 2007 to that in 2008?
Your answer should be very brief. 0.98. What is the ratio of the Value (constant 2005 US$) of Sub-Saharan Africa (developing only) in 2007 to that in 2009?
Your answer should be very brief. 0.88. What is the ratio of the Value (constant 2005 US$) in China in 2007 to that in 2009?
Keep it short and to the point. 0.85. What is the ratio of the Value (constant 2005 US$) in Rwanda in 2007 to that in 2009?
Make the answer very short. 0.87. What is the ratio of the Value (constant 2005 US$) of Sub-Saharan Africa (developing only) in 2007 to that in 2010?
Offer a terse response. 0.83. What is the ratio of the Value (constant 2005 US$) in China in 2007 to that in 2010?
Make the answer very short. 0.77. What is the ratio of the Value (constant 2005 US$) in Rwanda in 2007 to that in 2010?
Offer a terse response. 0.79. What is the ratio of the Value (constant 2005 US$) in Sub-Saharan Africa (developing only) in 2008 to that in 2009?
Provide a short and direct response. 0.95. What is the ratio of the Value (constant 2005 US$) of China in 2008 to that in 2009?
Your answer should be very brief. 0.92. What is the ratio of the Value (constant 2005 US$) of Rwanda in 2008 to that in 2009?
Make the answer very short. 0.9. What is the ratio of the Value (constant 2005 US$) in Sub-Saharan Africa (developing only) in 2008 to that in 2010?
Your answer should be compact. 0.9. What is the ratio of the Value (constant 2005 US$) of China in 2008 to that in 2010?
Give a very brief answer. 0.83. What is the ratio of the Value (constant 2005 US$) of Rwanda in 2008 to that in 2010?
Offer a terse response. 0.81. What is the ratio of the Value (constant 2005 US$) in Sub-Saharan Africa (developing only) in 2009 to that in 2010?
Give a very brief answer. 0.95. What is the ratio of the Value (constant 2005 US$) in China in 2009 to that in 2010?
Your answer should be compact. 0.9. What is the ratio of the Value (constant 2005 US$) in Rwanda in 2009 to that in 2010?
Give a very brief answer. 0.91. What is the difference between the highest and the second highest Value (constant 2005 US$) in Sub-Saharan Africa (developing only)?
Your answer should be compact. 7.61e+09. What is the difference between the highest and the second highest Value (constant 2005 US$) in China?
Offer a terse response. 5.12e+1. What is the difference between the highest and the second highest Value (constant 2005 US$) of Rwanda?
Provide a short and direct response. 6.08e+07. What is the difference between the highest and the lowest Value (constant 2005 US$) in Sub-Saharan Africa (developing only)?
Offer a very short reply. 6.05e+1. What is the difference between the highest and the lowest Value (constant 2005 US$) of China?
Offer a terse response. 2.49e+11. What is the difference between the highest and the lowest Value (constant 2005 US$) in Rwanda?
Keep it short and to the point. 2.89e+08. 